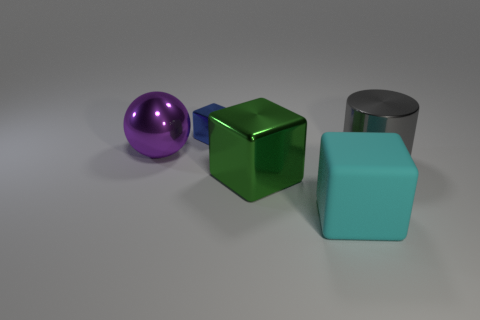What number of large blue balls are made of the same material as the small cube?
Your answer should be very brief. 0. What number of other things are the same size as the cyan rubber cube?
Provide a short and direct response. 3. Is there a gray metal thing of the same size as the purple ball?
Ensure brevity in your answer.  Yes. How many objects are cyan blocks or small shiny objects?
Provide a succinct answer. 2. There is a block left of the green metallic object; is its size the same as the big purple metallic ball?
Your answer should be very brief. No. There is a object that is right of the large shiny ball and behind the gray object; how big is it?
Offer a terse response. Small. What number of other things are the same shape as the purple thing?
Offer a terse response. 0. What number of other things are there of the same material as the big gray cylinder
Provide a short and direct response. 3. There is a green thing that is the same shape as the cyan object; what is its size?
Make the answer very short. Large. There is a metallic thing that is in front of the blue metal object and behind the big gray metallic cylinder; what color is it?
Your answer should be very brief. Purple. 